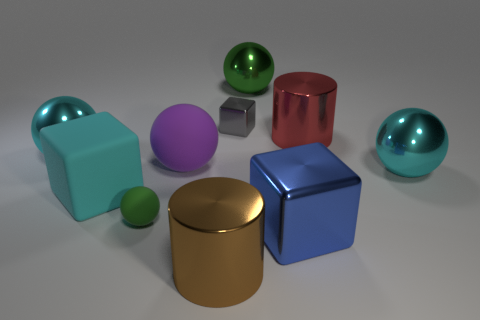How many cyan balls must be subtracted to get 1 cyan balls? 1 Subtract all purple spheres. How many spheres are left? 4 Subtract all yellow blocks. Subtract all yellow cylinders. How many blocks are left? 3 Subtract all cylinders. How many objects are left? 8 Add 1 yellow matte cylinders. How many yellow matte cylinders exist? 1 Subtract 1 purple balls. How many objects are left? 9 Subtract all large red cylinders. Subtract all cylinders. How many objects are left? 7 Add 2 large cyan metal balls. How many large cyan metal balls are left? 4 